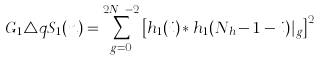Convert formula to latex. <formula><loc_0><loc_0><loc_500><loc_500>G _ { 1 } \triangle q S _ { 1 } ( n ) = \sum _ { g = 0 } ^ { 2 N _ { h } - 2 } \left [ h _ { 1 } ( i ) * h _ { 1 } ( N _ { h } - 1 - i ) | _ { g } \right ] ^ { 2 }</formula> 